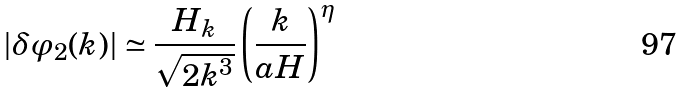<formula> <loc_0><loc_0><loc_500><loc_500>| \delta \varphi _ { 2 } ( k ) | \simeq \frac { H _ { k } } { \sqrt { 2 k ^ { 3 } } } \left ( \frac { k } { a H } \right ) ^ { \eta }</formula> 